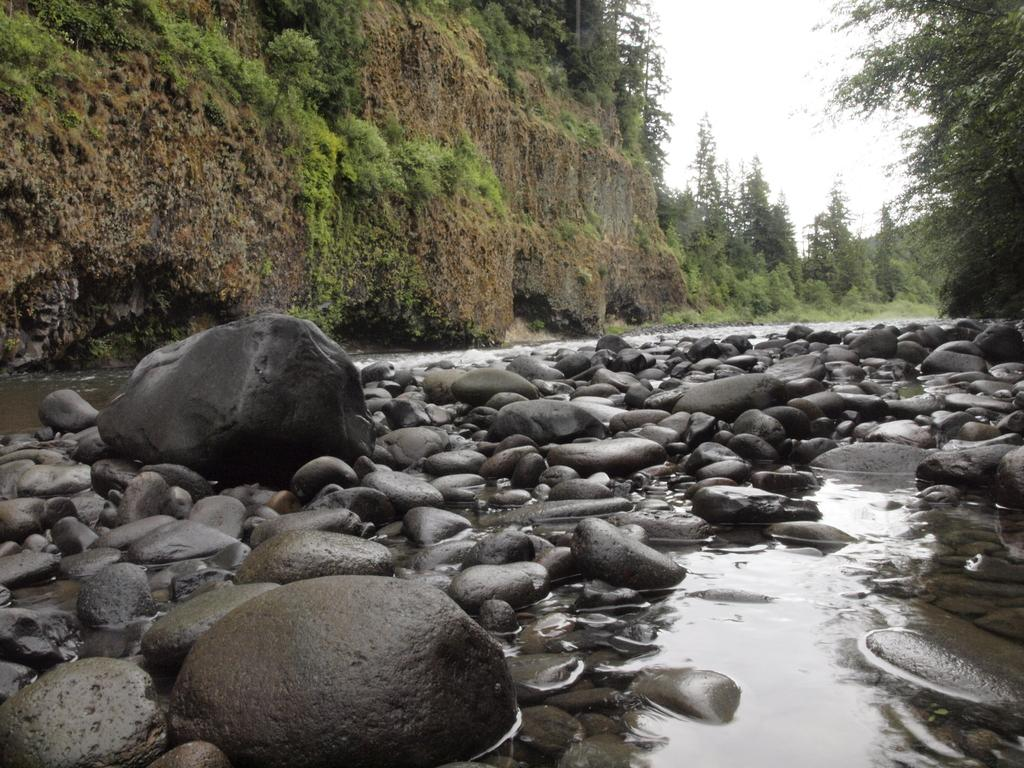What is located at the bottom of the image? There are black stones and water visible at the bottom of the image. What can be seen in the background of the image? There is a mountain, trees, and plants visible in the background of the image. What is visible at the top of the image? The sky is visible at the top of the image. What can be observed in the sky? Clouds are present in the sky. What type of jewel is the son holding in the image? There is no son or jewel present in the image. What are the people in the image talking about? There are no people visible in the image, so it is not possible to determine what they might be talking about. 